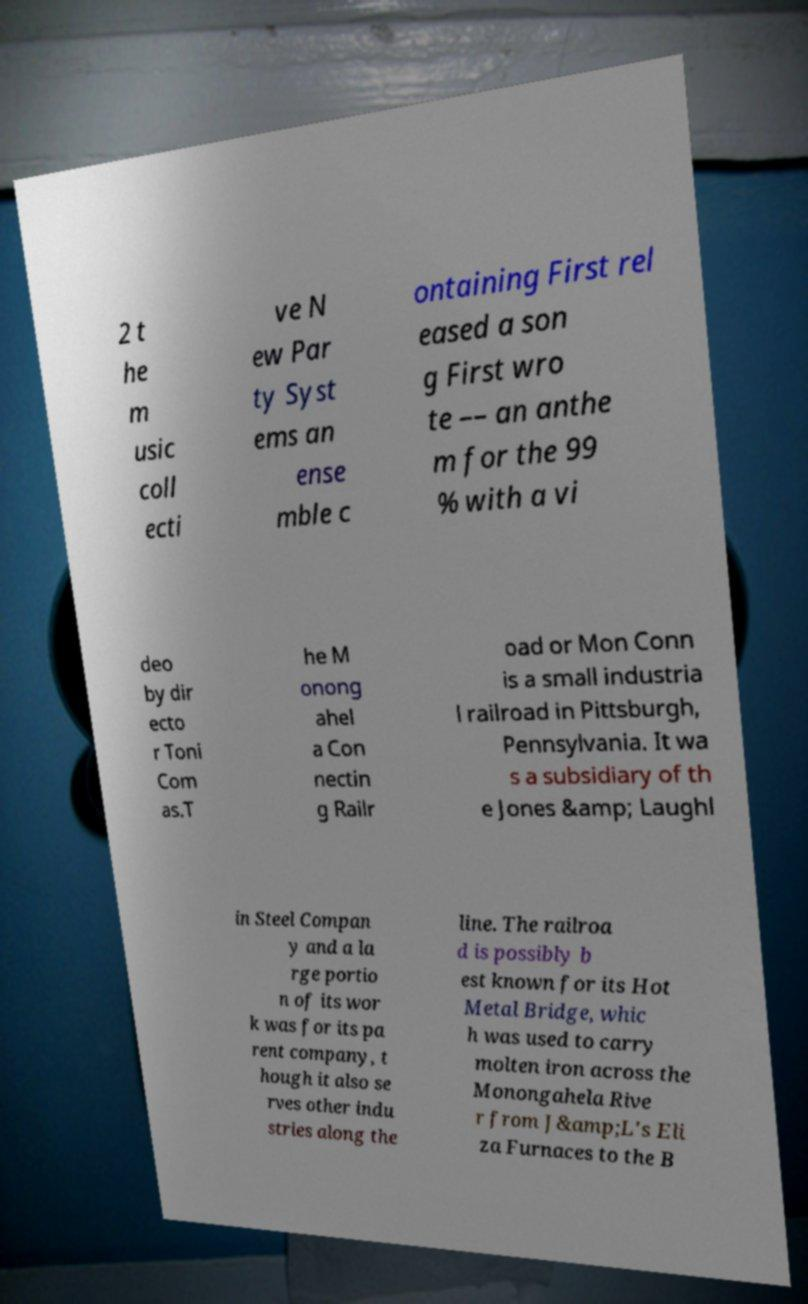For documentation purposes, I need the text within this image transcribed. Could you provide that? 2 t he m usic coll ecti ve N ew Par ty Syst ems an ense mble c ontaining First rel eased a son g First wro te –– an anthe m for the 99 % with a vi deo by dir ecto r Toni Com as.T he M onong ahel a Con nectin g Railr oad or Mon Conn is a small industria l railroad in Pittsburgh, Pennsylvania. It wa s a subsidiary of th e Jones &amp; Laughl in Steel Compan y and a la rge portio n of its wor k was for its pa rent company, t hough it also se rves other indu stries along the line. The railroa d is possibly b est known for its Hot Metal Bridge, whic h was used to carry molten iron across the Monongahela Rive r from J&amp;L's Eli za Furnaces to the B 